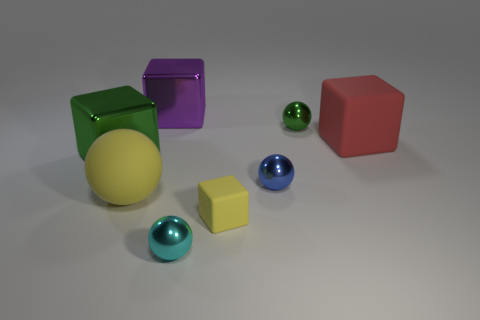Subtract all large red blocks. How many blocks are left? 3 Add 2 big blue metal objects. How many objects exist? 10 Subtract 1 blocks. How many blocks are left? 3 Subtract all cyan balls. How many balls are left? 3 Add 8 blue metal spheres. How many blue metal spheres exist? 9 Subtract 0 cyan cylinders. How many objects are left? 8 Subtract all gray balls. Subtract all cyan cubes. How many balls are left? 4 Subtract all purple balls. How many brown cubes are left? 0 Subtract all green blocks. Subtract all tiny blue matte cubes. How many objects are left? 7 Add 5 large red matte objects. How many large red matte objects are left? 6 